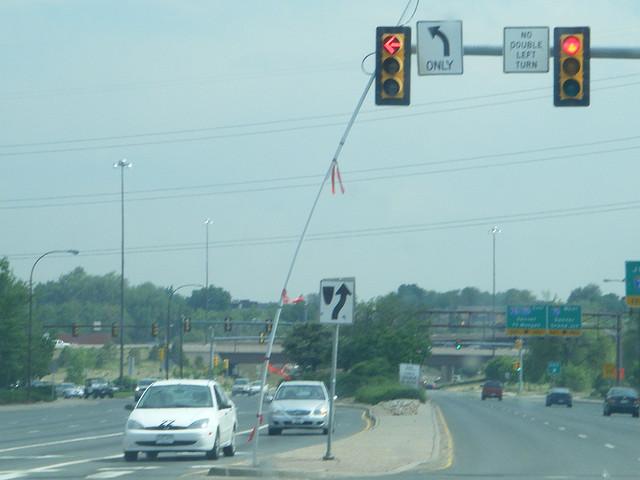How many cars are there in the picture?
Write a very short answer. 11. How is the traffic light?
Answer briefly. Red. What do the signs say?
Give a very brief answer. Only. Is it ok for left turning traffic to go now?
Be succinct. No. 